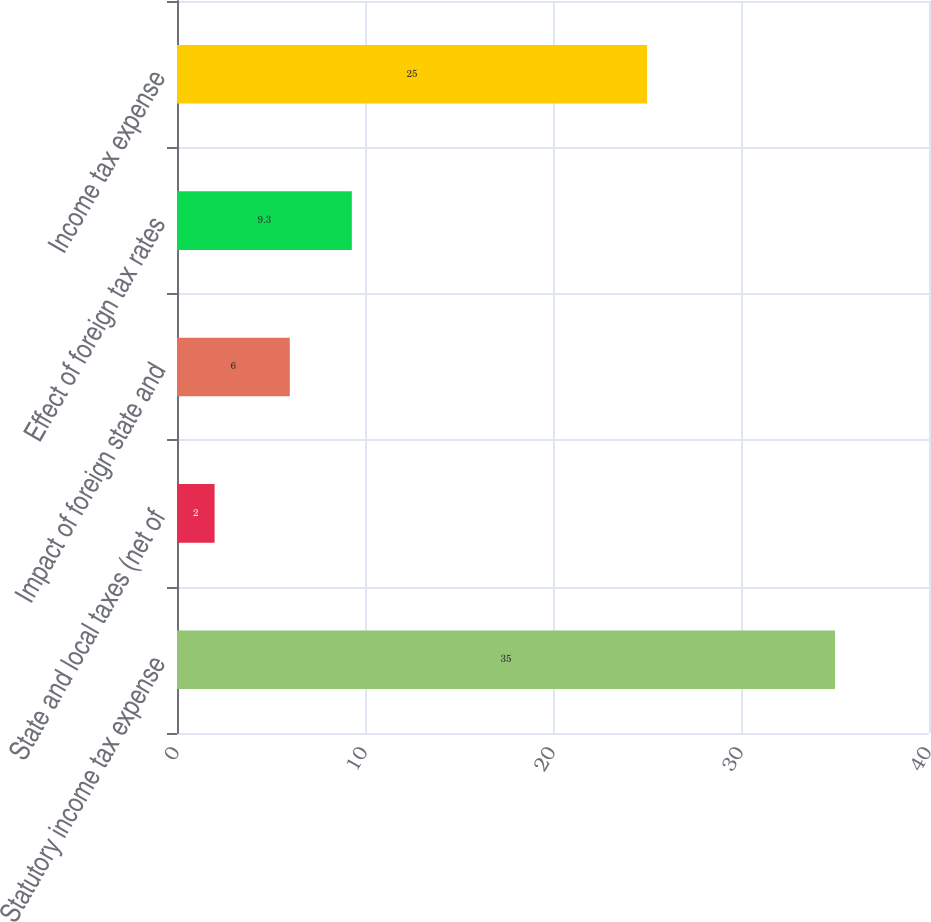Convert chart. <chart><loc_0><loc_0><loc_500><loc_500><bar_chart><fcel>Statutory income tax expense<fcel>State and local taxes (net of<fcel>Impact of foreign state and<fcel>Effect of foreign tax rates<fcel>Income tax expense<nl><fcel>35<fcel>2<fcel>6<fcel>9.3<fcel>25<nl></chart> 